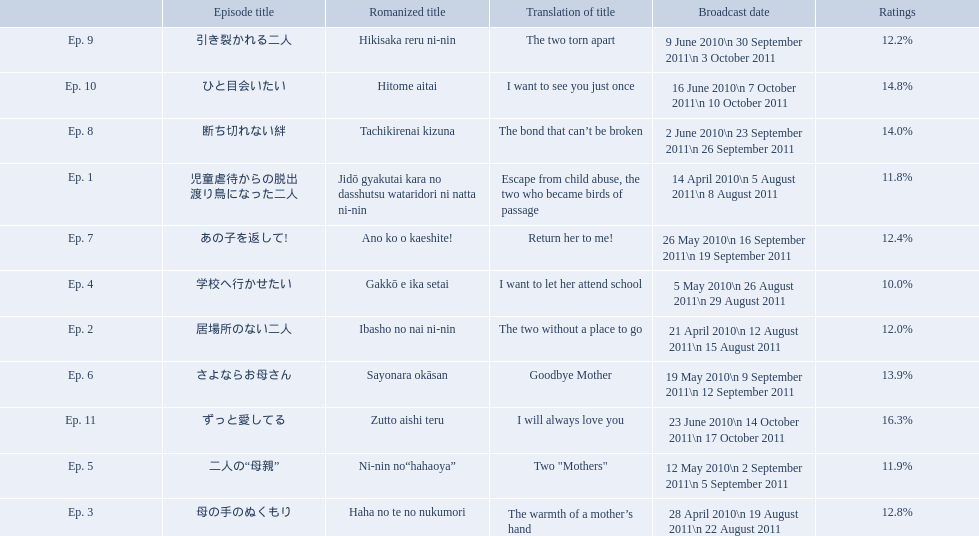What were the episode titles of mother? 児童虐待からの脱出 渡り鳥になった二人, 居場所のない二人, 母の手のぬくもり, 学校へ行かせたい, 二人の“母親”, さよならお母さん, あの子を返して!, 断ち切れない絆, 引き裂かれる二人, ひと目会いたい, ずっと愛してる. Which of these episodes had the highest ratings? ずっと愛してる. 